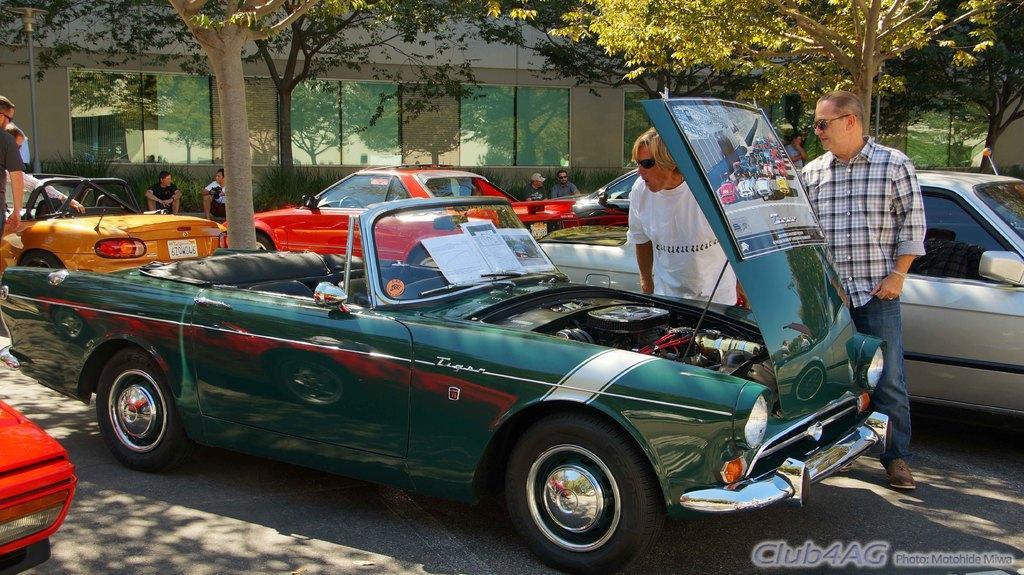Describe this image in one or two sentences. This picture is clicked outside the city. Here, we see many cars parked outside the city. The man in the white t-shirt is standing beside the green car and I think he might be repairing the car. Beside him, the man in black and white check shirt is standing. In the background, there are many trees and we even see a building in the background. 